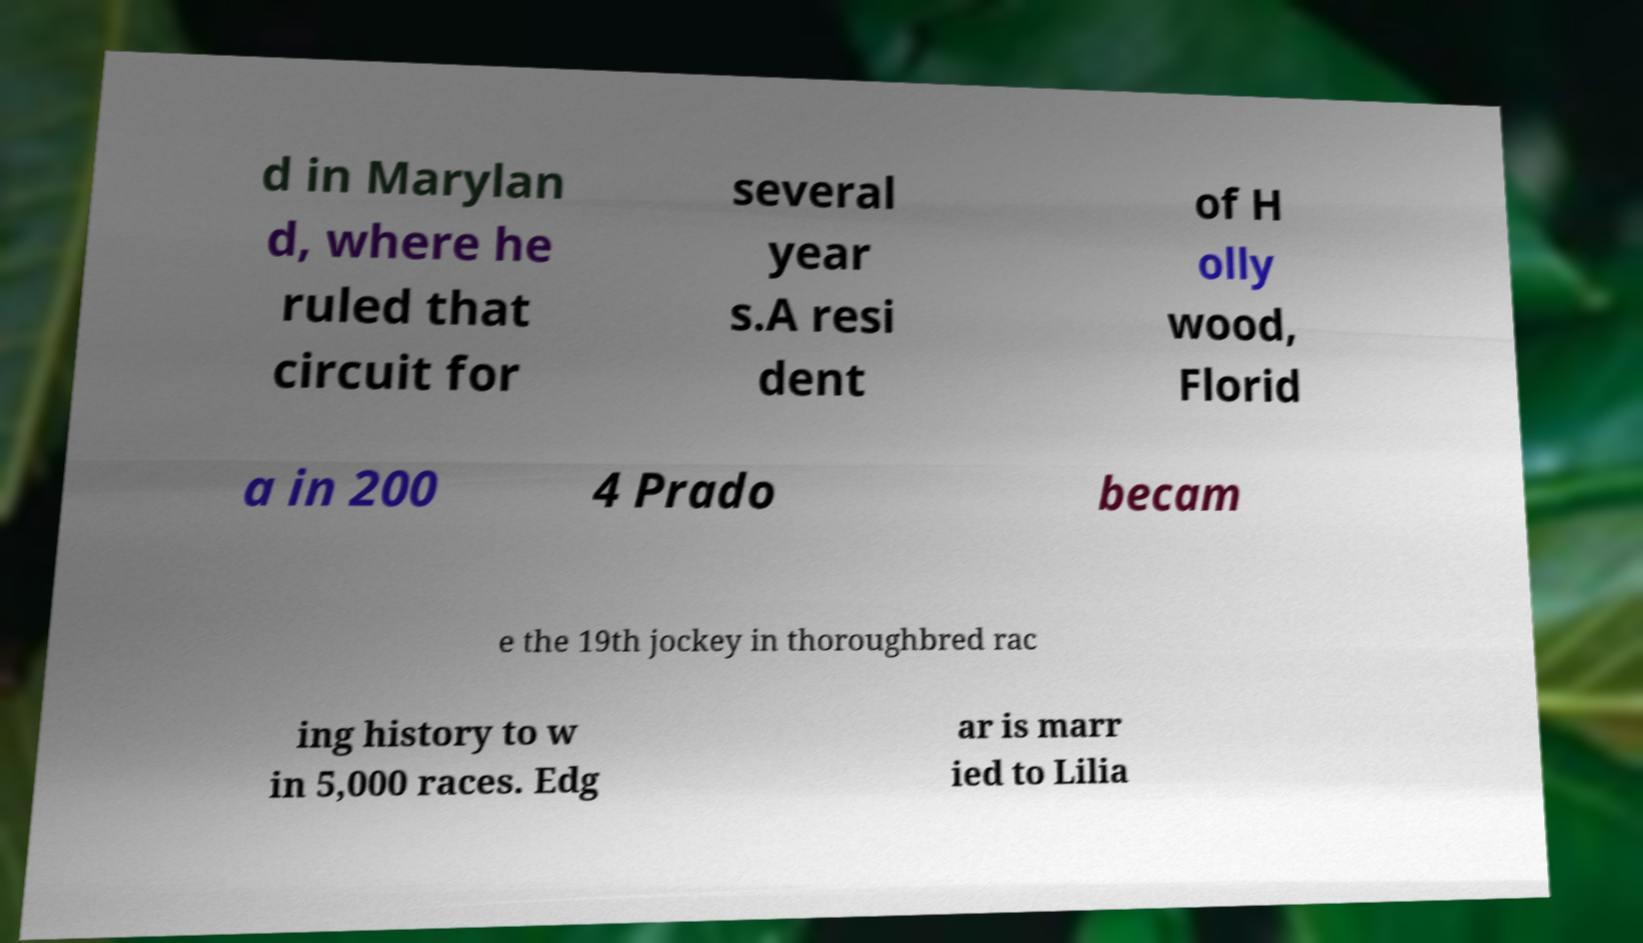I need the written content from this picture converted into text. Can you do that? d in Marylan d, where he ruled that circuit for several year s.A resi dent of H olly wood, Florid a in 200 4 Prado becam e the 19th jockey in thoroughbred rac ing history to w in 5,000 races. Edg ar is marr ied to Lilia 